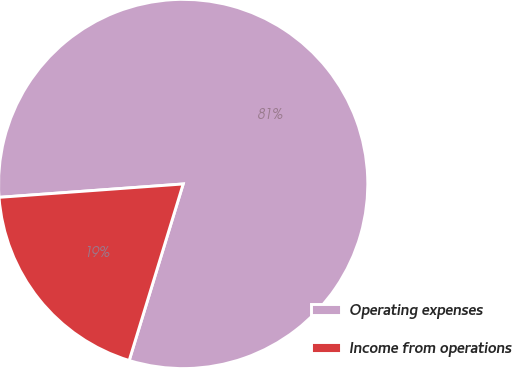Convert chart to OTSL. <chart><loc_0><loc_0><loc_500><loc_500><pie_chart><fcel>Operating expenses<fcel>Income from operations<nl><fcel>80.88%<fcel>19.12%<nl></chart> 